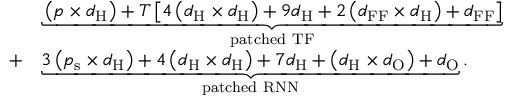Convert formula to latex. <formula><loc_0><loc_0><loc_500><loc_500>\begin{array} { r l } & { \underbrace { \left ( p \times d _ { H } \right ) + T \left [ 4 \left ( d _ { H } \times d _ { H } \right ) + 9 d _ { H } + 2 \left ( d _ { F F } \times d _ { H } \right ) + d _ { F F } \right ] } _ { p a t c h e d \ T F } } \\ { + } & { \underbrace { 3 \left ( p _ { s } \times d _ { H } \right ) + 4 \left ( d _ { H } \times d _ { H } \right ) + 7 d _ { H } + \left ( d _ { H } \times d _ { O } \right ) + d _ { O } } _ { p a t c h e d \ R N N } . } \end{array}</formula> 